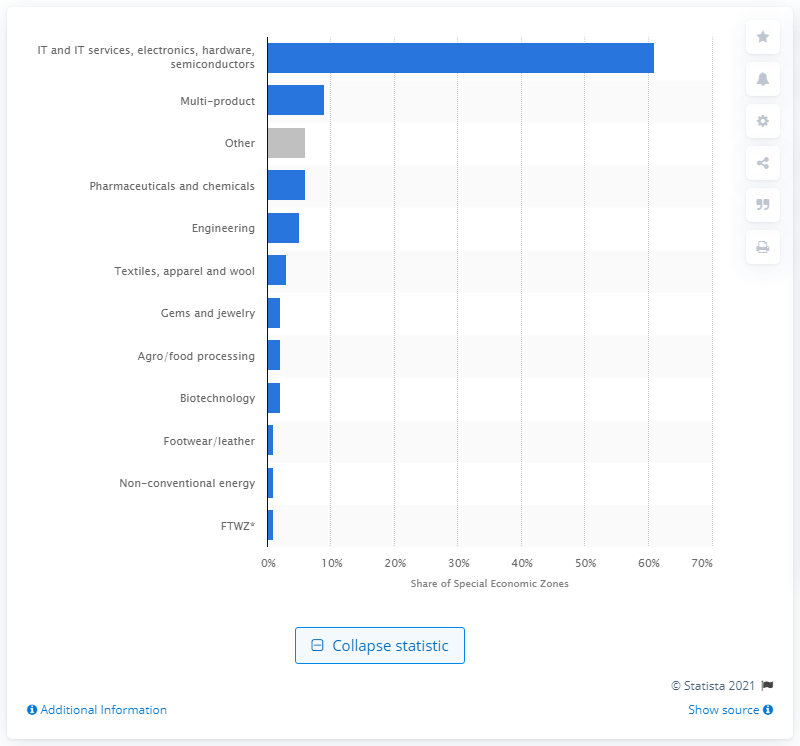Specify some key components in this picture. Sixty-one percent of the total share of Special Economic Zones was comprised of IT/ITES/Electronic/Hardware/Semiconductor industries. 